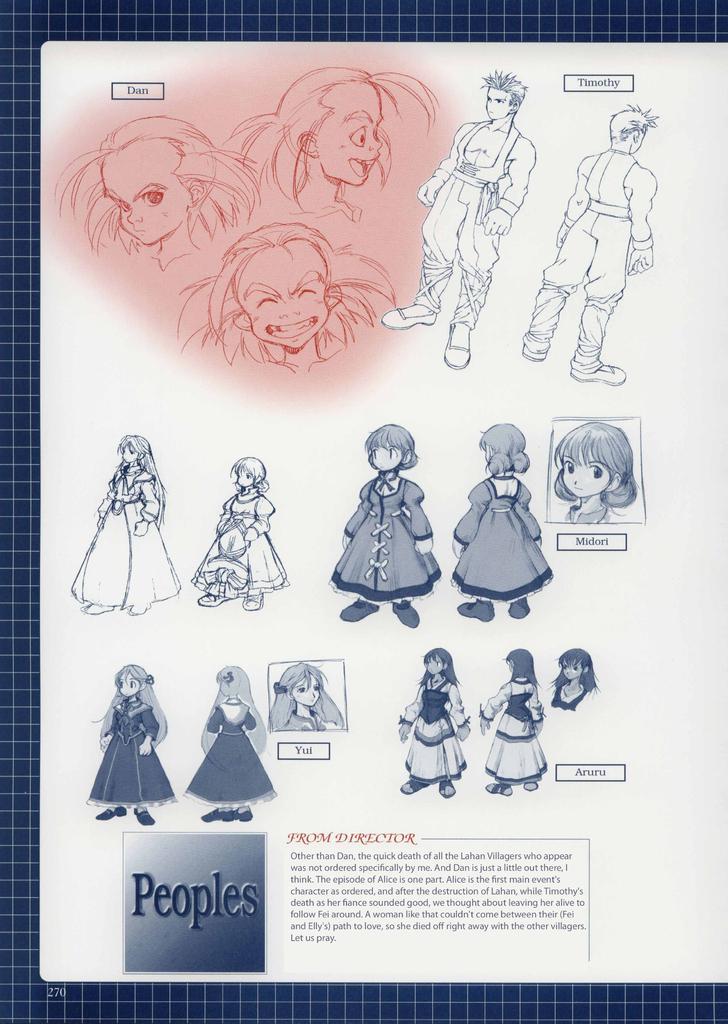Please provide a concise description of this image. In this image I can see white colour thing and on it I can see depiction of people. I can also see something is written over here. 